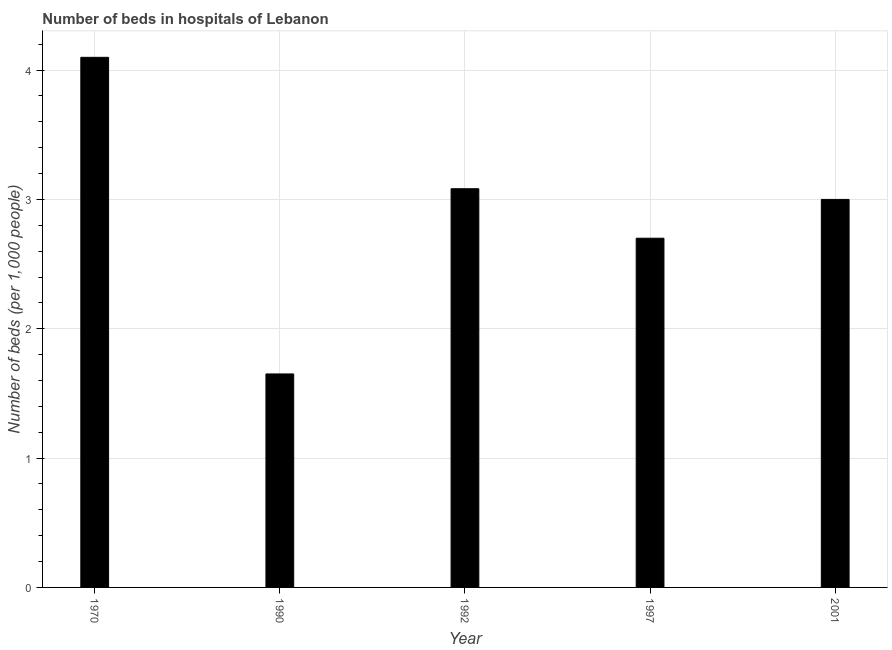Does the graph contain grids?
Offer a terse response. Yes. What is the title of the graph?
Offer a terse response. Number of beds in hospitals of Lebanon. What is the label or title of the X-axis?
Offer a terse response. Year. What is the label or title of the Y-axis?
Keep it short and to the point. Number of beds (per 1,0 people). What is the number of hospital beds in 1990?
Your answer should be very brief. 1.65. Across all years, what is the maximum number of hospital beds?
Provide a succinct answer. 4.1. Across all years, what is the minimum number of hospital beds?
Ensure brevity in your answer.  1.65. In which year was the number of hospital beds maximum?
Keep it short and to the point. 1970. In which year was the number of hospital beds minimum?
Ensure brevity in your answer.  1990. What is the sum of the number of hospital beds?
Offer a terse response. 14.53. What is the difference between the number of hospital beds in 1970 and 1997?
Offer a very short reply. 1.4. What is the average number of hospital beds per year?
Provide a short and direct response. 2.91. What is the median number of hospital beds?
Your response must be concise. 3. What is the ratio of the number of hospital beds in 1990 to that in 1997?
Give a very brief answer. 0.61. Is the number of hospital beds in 1990 less than that in 1992?
Ensure brevity in your answer.  Yes. Is the difference between the number of hospital beds in 1990 and 2001 greater than the difference between any two years?
Your response must be concise. No. What is the difference between the highest and the second highest number of hospital beds?
Provide a succinct answer. 1.02. What is the difference between the highest and the lowest number of hospital beds?
Provide a succinct answer. 2.45. In how many years, is the number of hospital beds greater than the average number of hospital beds taken over all years?
Your response must be concise. 3. How many years are there in the graph?
Your answer should be compact. 5. What is the difference between two consecutive major ticks on the Y-axis?
Give a very brief answer. 1. Are the values on the major ticks of Y-axis written in scientific E-notation?
Give a very brief answer. No. What is the Number of beds (per 1,000 people) in 1970?
Your answer should be compact. 4.1. What is the Number of beds (per 1,000 people) of 1990?
Offer a terse response. 1.65. What is the Number of beds (per 1,000 people) in 1992?
Your response must be concise. 3.08. What is the Number of beds (per 1,000 people) in 1997?
Your answer should be compact. 2.7. What is the Number of beds (per 1,000 people) in 2001?
Give a very brief answer. 3. What is the difference between the Number of beds (per 1,000 people) in 1970 and 1990?
Offer a very short reply. 2.45. What is the difference between the Number of beds (per 1,000 people) in 1970 and 1997?
Make the answer very short. 1.4. What is the difference between the Number of beds (per 1,000 people) in 1970 and 2001?
Your answer should be very brief. 1.1. What is the difference between the Number of beds (per 1,000 people) in 1990 and 1992?
Your response must be concise. -1.43. What is the difference between the Number of beds (per 1,000 people) in 1990 and 1997?
Offer a very short reply. -1.05. What is the difference between the Number of beds (per 1,000 people) in 1990 and 2001?
Make the answer very short. -1.35. What is the difference between the Number of beds (per 1,000 people) in 1992 and 1997?
Offer a very short reply. 0.38. What is the difference between the Number of beds (per 1,000 people) in 1992 and 2001?
Give a very brief answer. 0.08. What is the ratio of the Number of beds (per 1,000 people) in 1970 to that in 1990?
Offer a very short reply. 2.48. What is the ratio of the Number of beds (per 1,000 people) in 1970 to that in 1992?
Ensure brevity in your answer.  1.33. What is the ratio of the Number of beds (per 1,000 people) in 1970 to that in 1997?
Provide a short and direct response. 1.52. What is the ratio of the Number of beds (per 1,000 people) in 1970 to that in 2001?
Your answer should be compact. 1.37. What is the ratio of the Number of beds (per 1,000 people) in 1990 to that in 1992?
Your response must be concise. 0.54. What is the ratio of the Number of beds (per 1,000 people) in 1990 to that in 1997?
Provide a succinct answer. 0.61. What is the ratio of the Number of beds (per 1,000 people) in 1990 to that in 2001?
Provide a short and direct response. 0.55. What is the ratio of the Number of beds (per 1,000 people) in 1992 to that in 1997?
Your answer should be compact. 1.14. What is the ratio of the Number of beds (per 1,000 people) in 1992 to that in 2001?
Keep it short and to the point. 1.03. 